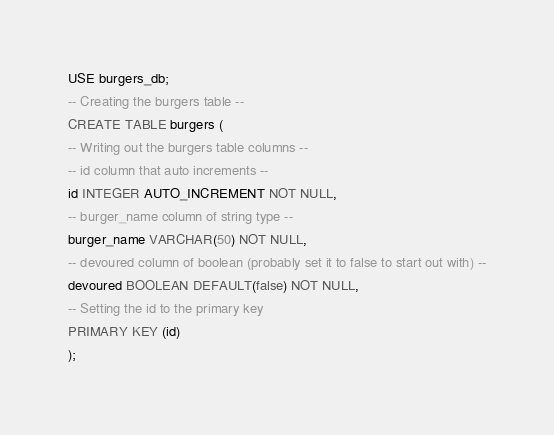Convert code to text. <code><loc_0><loc_0><loc_500><loc_500><_SQL_>USE burgers_db;
-- Creating the burgers table --
CREATE TABLE burgers (
-- Writing out the burgers table columns --
-- id column that auto increments --
id INTEGER AUTO_INCREMENT NOT NULL,
-- burger_name column of string type --
burger_name VARCHAR(50) NOT NULL,
-- devoured column of boolean (probably set it to false to start out with) --
devoured BOOLEAN DEFAULT(false) NOT NULL,
-- Setting the id to the primary key
PRIMARY KEY (id)
);</code> 